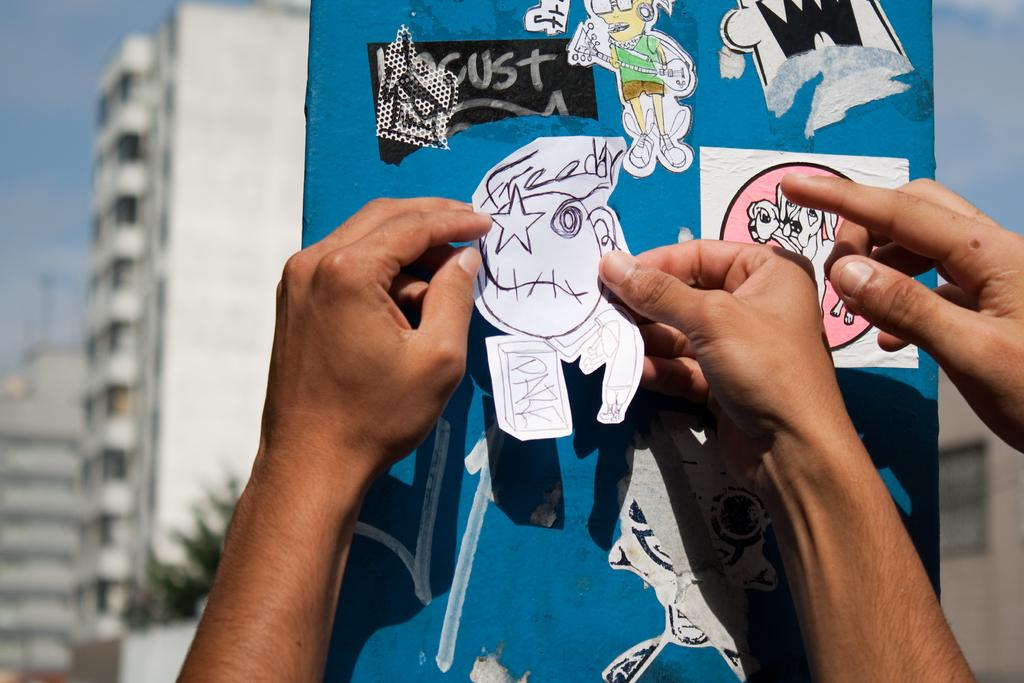What can be seen in the image that belongs to people? There are persons' hands in the image. What type of objects are present in the image? There are stickers in the image. What can be seen in the background of the image? There are trees, buildings, and the sky with clouds visible in the background of the image. How would you describe the quality of the image? The image is blurry. What type of thread is being used to create the weather in the image? There is no thread or weather depicted in the image; it features persons' hands, stickers, and a background with trees, buildings, and clouds. 